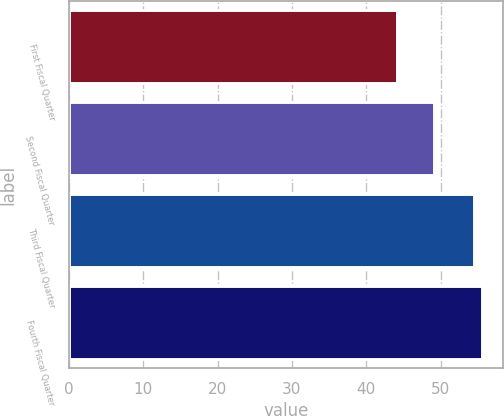Convert chart to OTSL. <chart><loc_0><loc_0><loc_500><loc_500><bar_chart><fcel>First Fiscal Quarter<fcel>Second Fiscal Quarter<fcel>Third Fiscal Quarter<fcel>Fourth Fiscal Quarter<nl><fcel>44.11<fcel>49.15<fcel>54.44<fcel>55.54<nl></chart> 